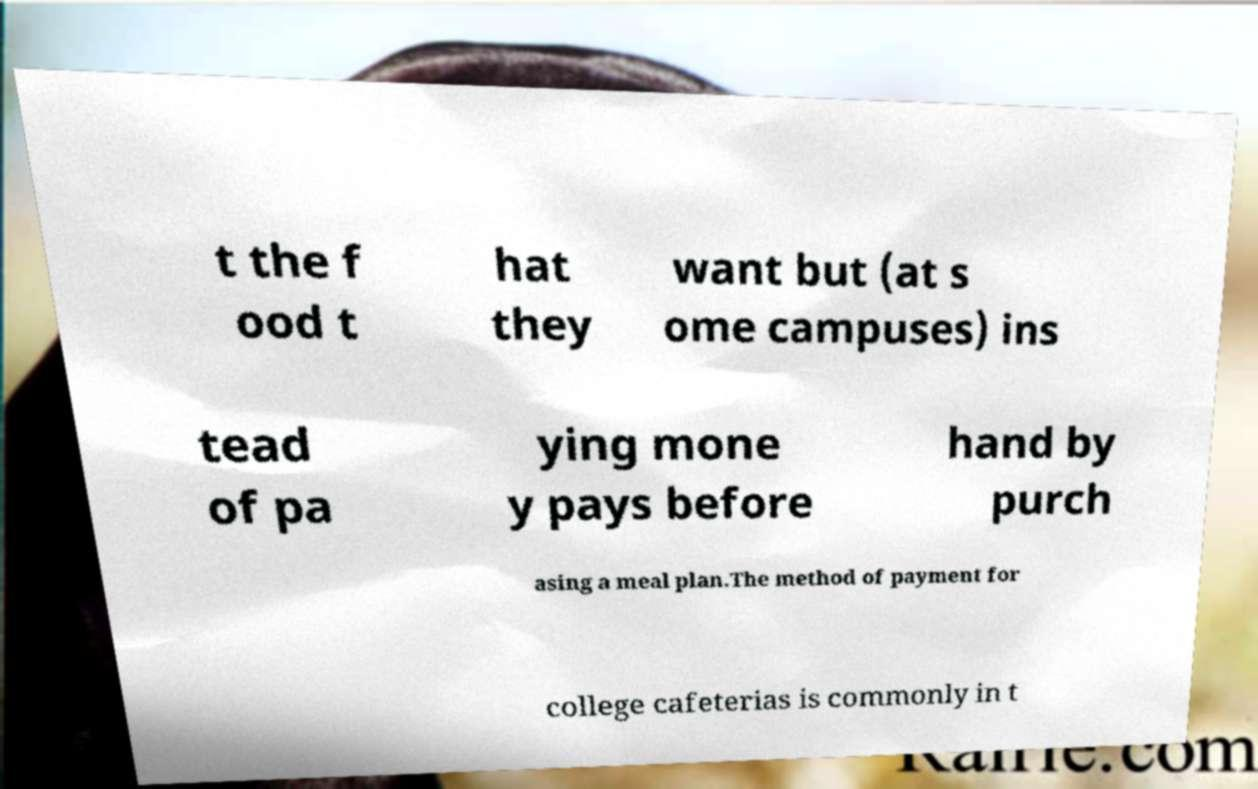What messages or text are displayed in this image? I need them in a readable, typed format. t the f ood t hat they want but (at s ome campuses) ins tead of pa ying mone y pays before hand by purch asing a meal plan.The method of payment for college cafeterias is commonly in t 